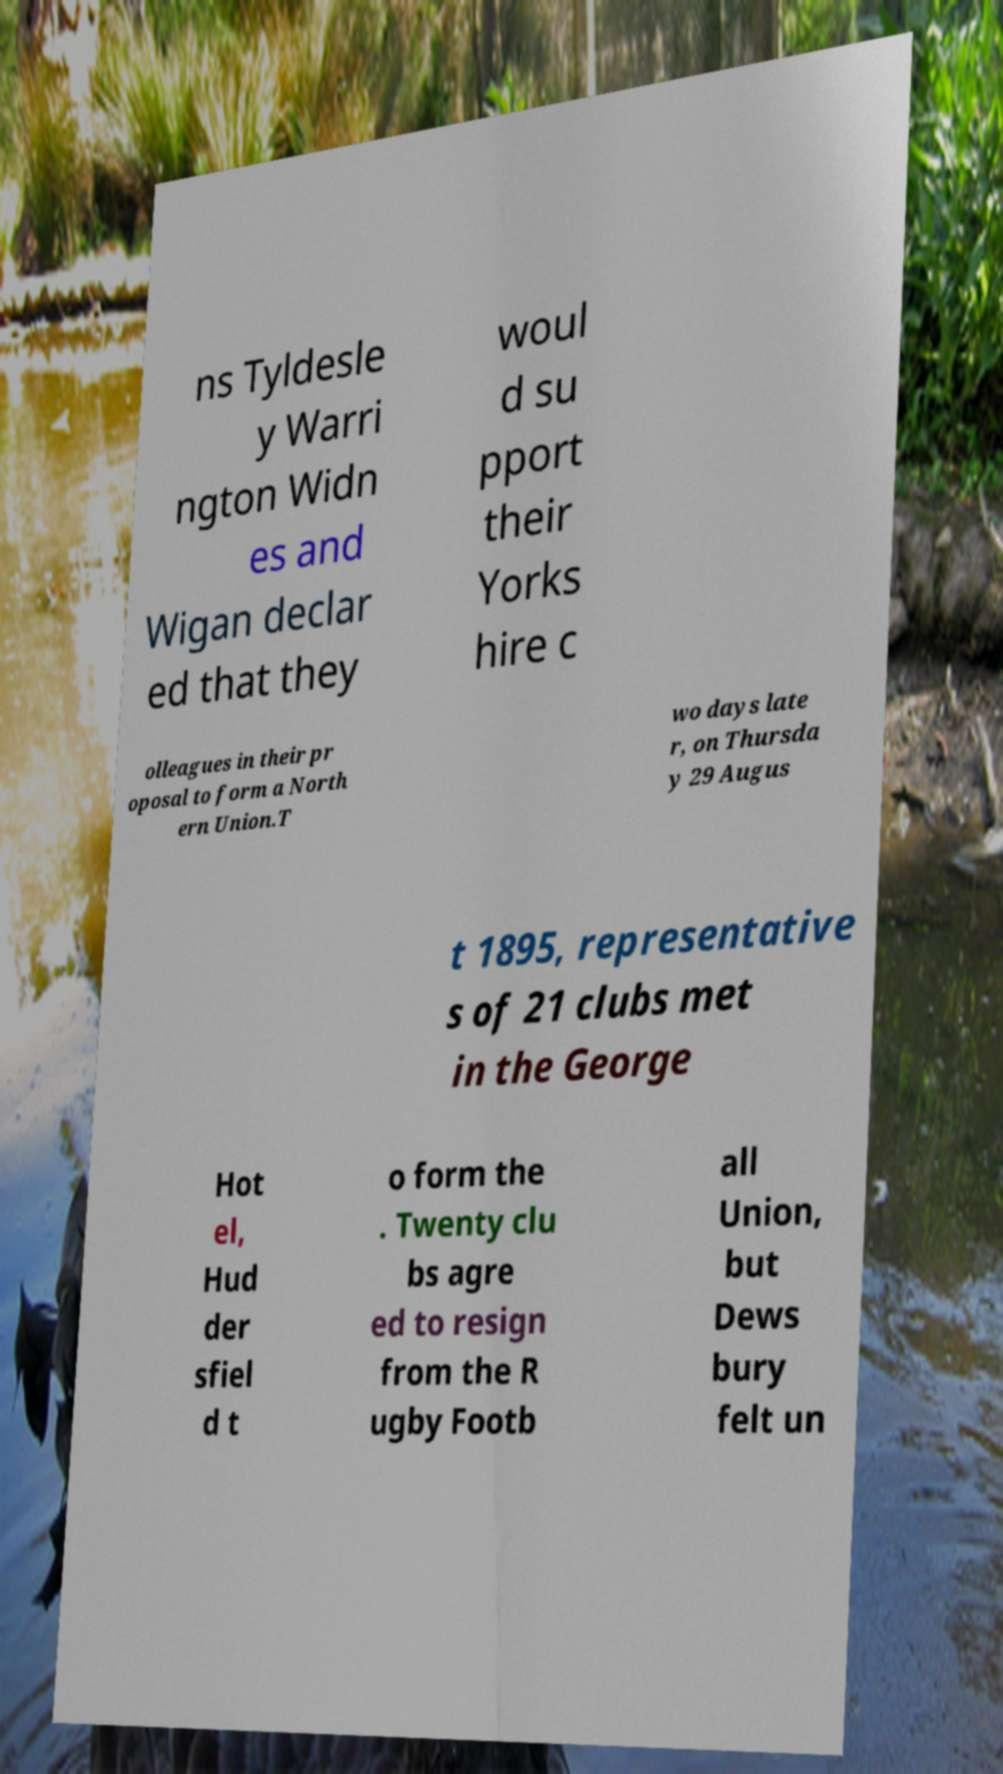Could you assist in decoding the text presented in this image and type it out clearly? ns Tyldesle y Warri ngton Widn es and Wigan declar ed that they woul d su pport their Yorks hire c olleagues in their pr oposal to form a North ern Union.T wo days late r, on Thursda y 29 Augus t 1895, representative s of 21 clubs met in the George Hot el, Hud der sfiel d t o form the . Twenty clu bs agre ed to resign from the R ugby Footb all Union, but Dews bury felt un 